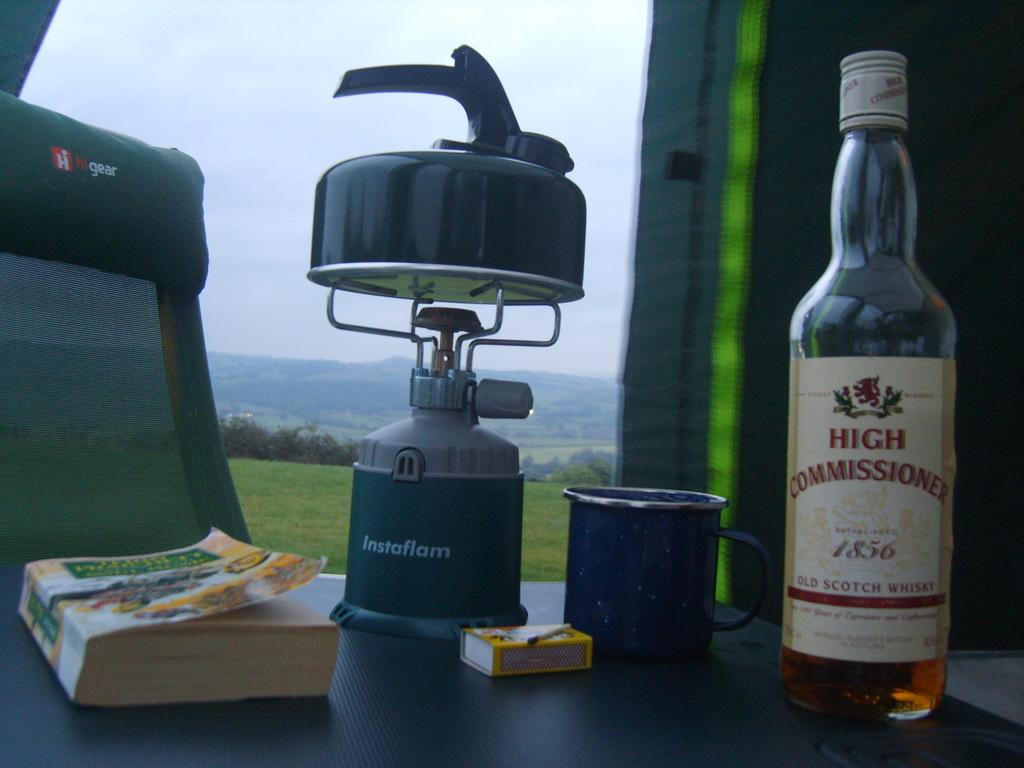<image>
Give a short and clear explanation of the subsequent image. High Commissioner bottle next to a Instaflam device on a table. 